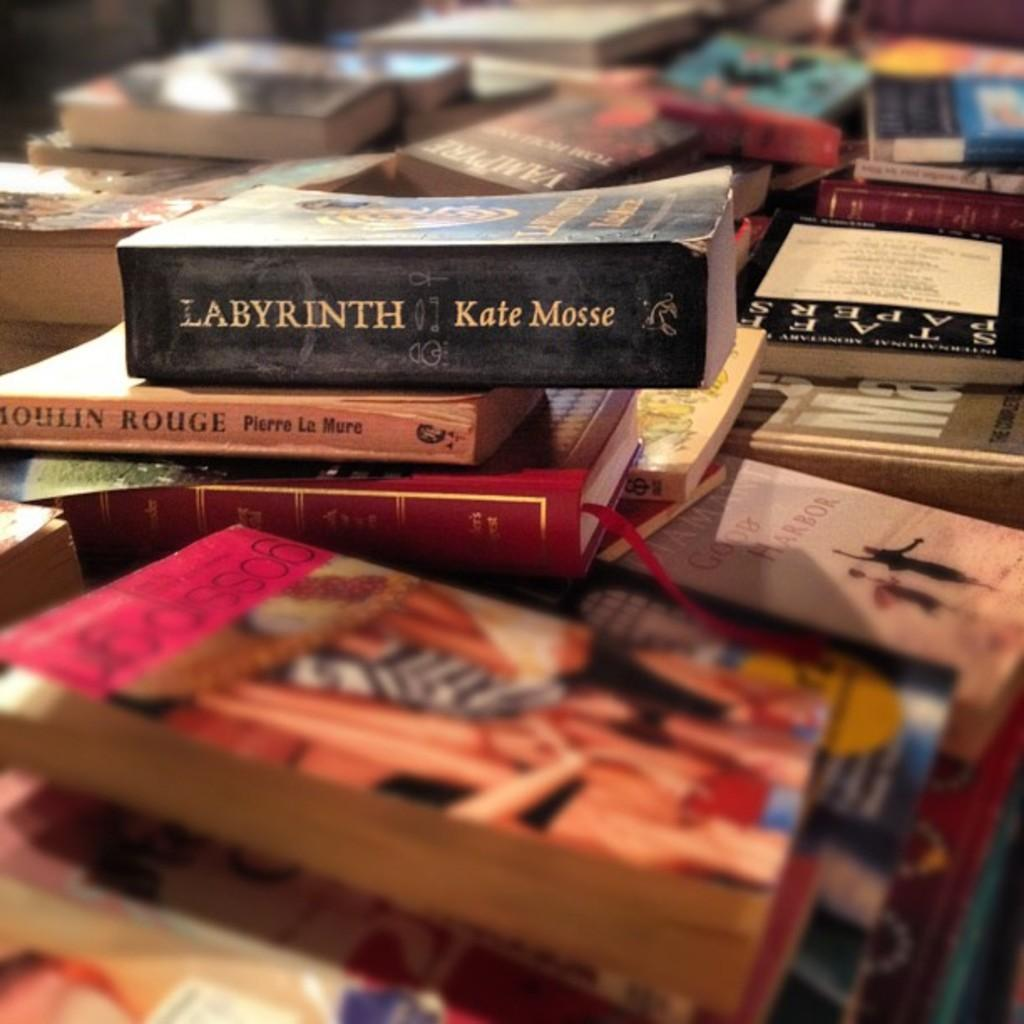Provide a one-sentence caption for the provided image. Book named Labyrinth written by Kate Mosse on top of a stack of other books. 